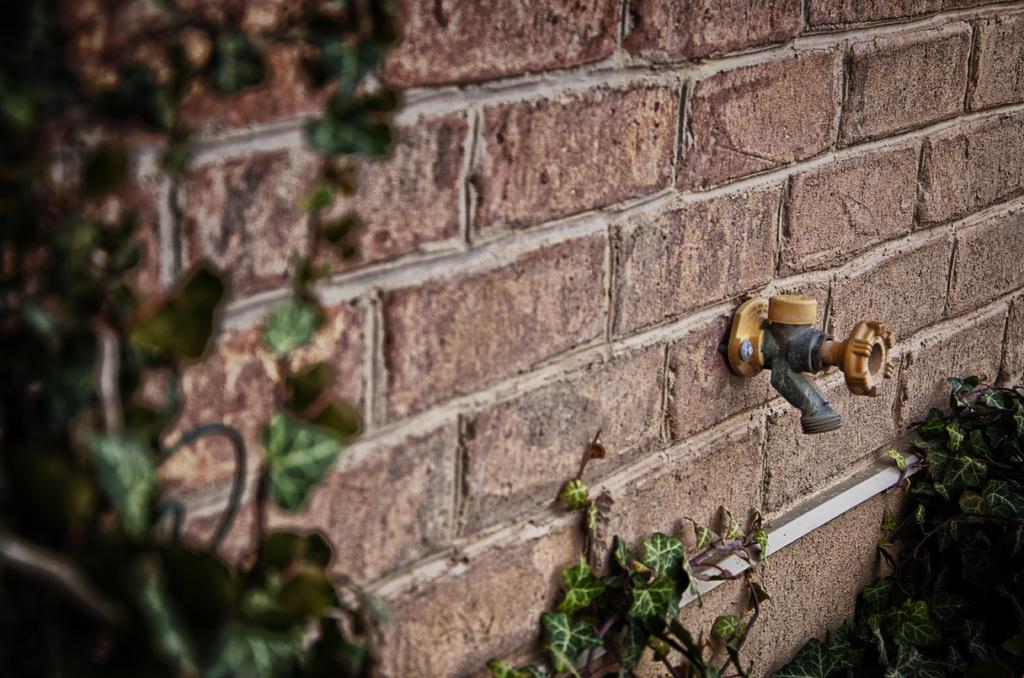Please provide a concise description of this image. In this image in the front there are leaves and in the center there is a tap on the wall. 